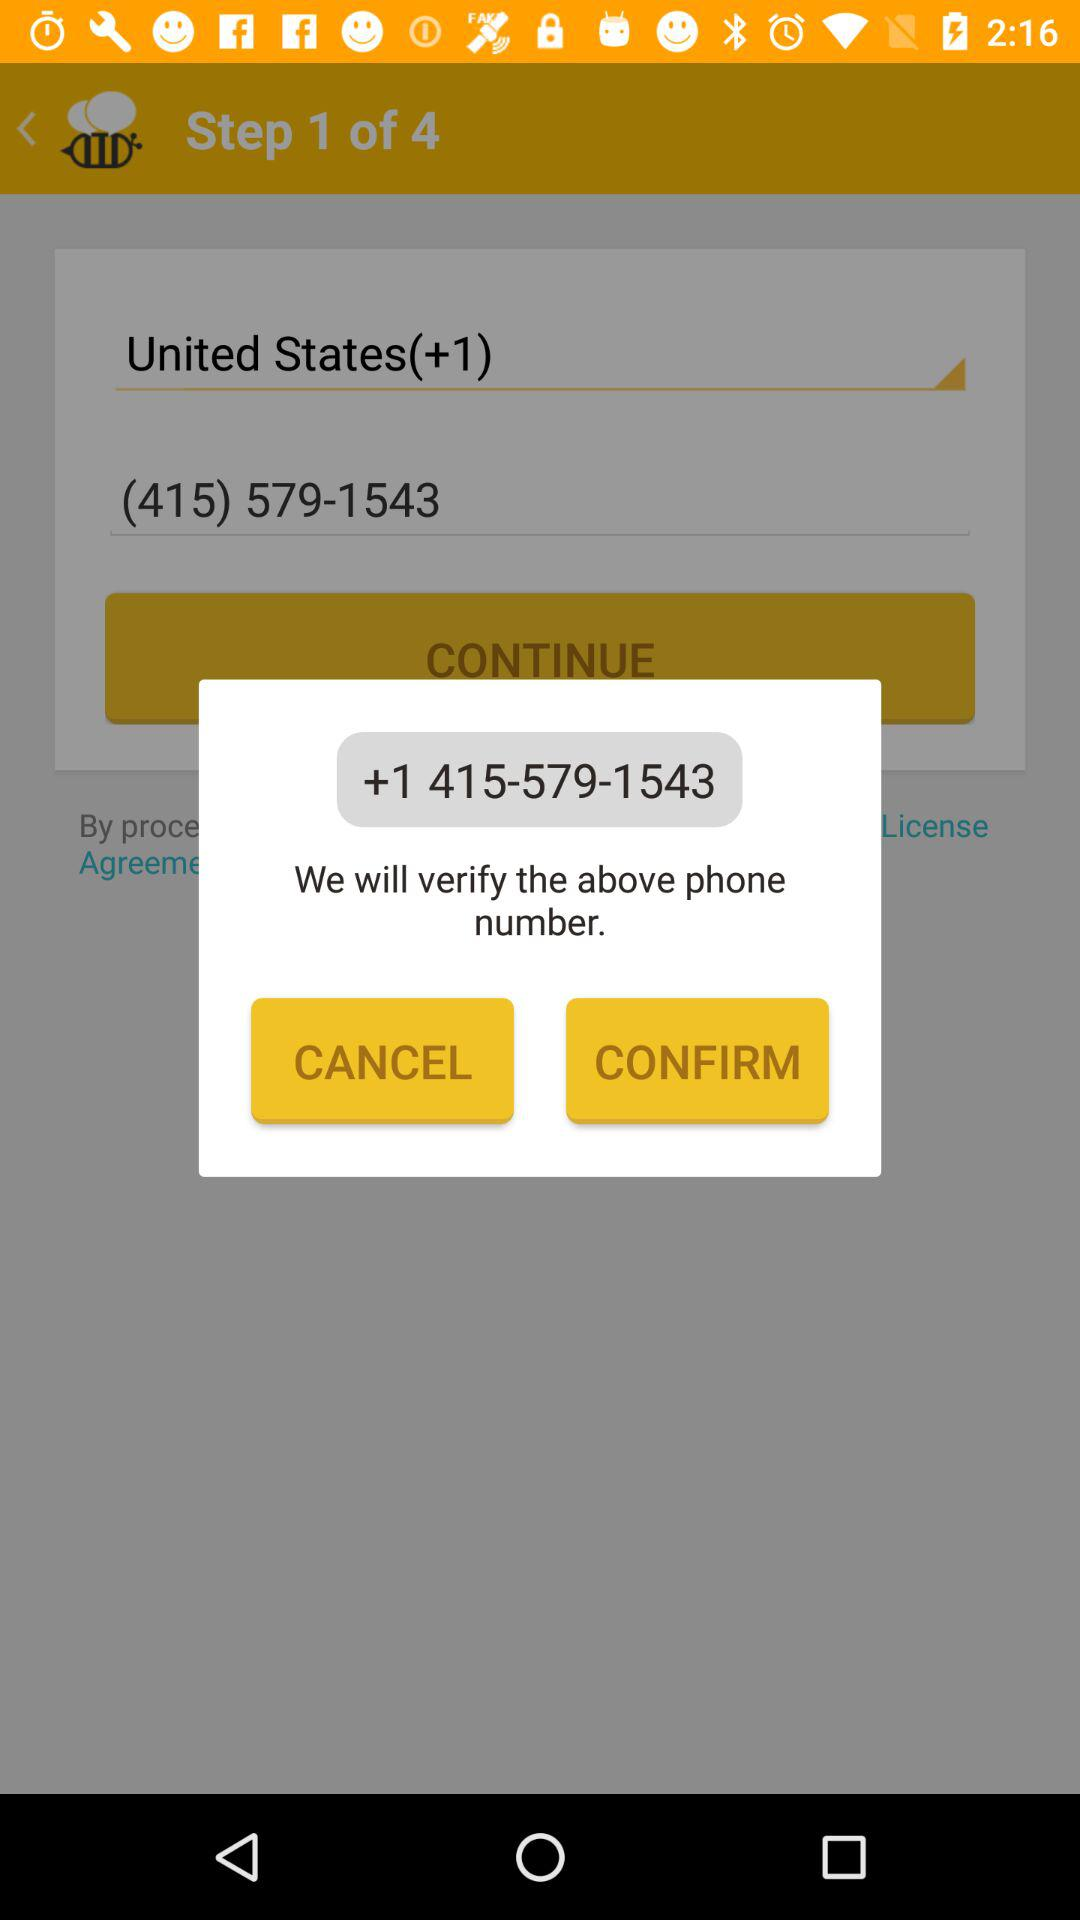What is the country name mentioned? The country name mentioned is the United States. 